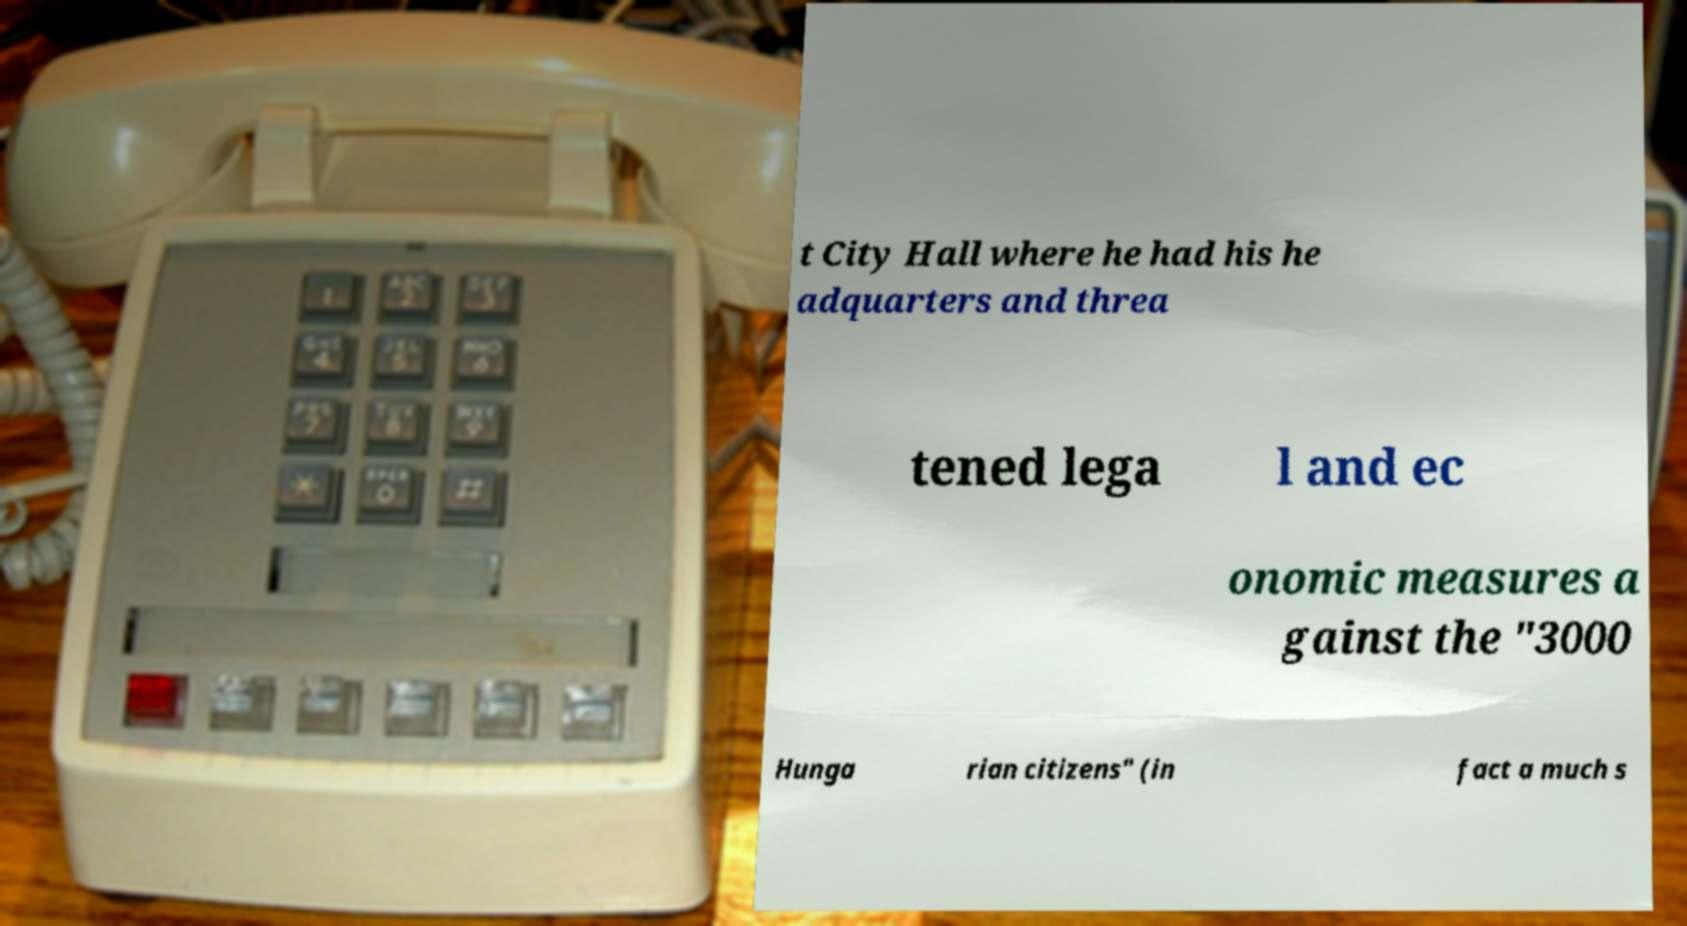Please identify and transcribe the text found in this image. t City Hall where he had his he adquarters and threa tened lega l and ec onomic measures a gainst the "3000 Hunga rian citizens" (in fact a much s 